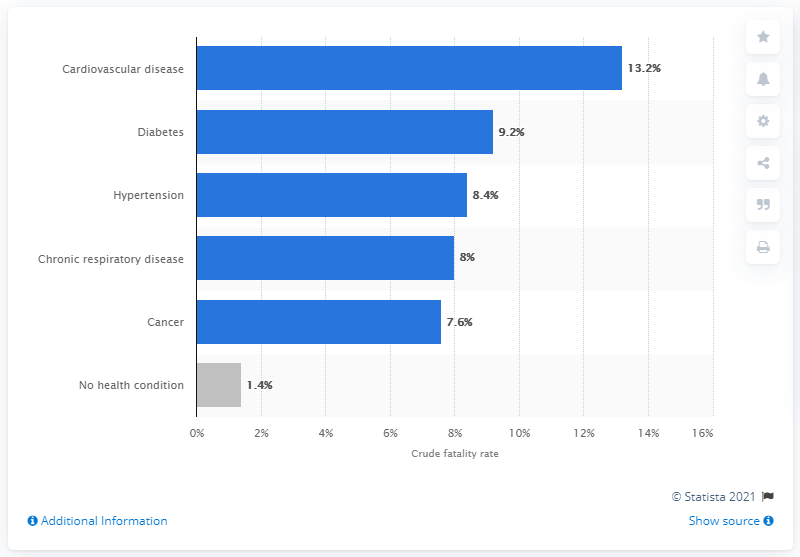Mention a couple of crucial points in this snapshot. As of February 20, 2020, the crude fatality rate of COVID-19 among patients with cardiovascular diseases in China was 13.2%. 